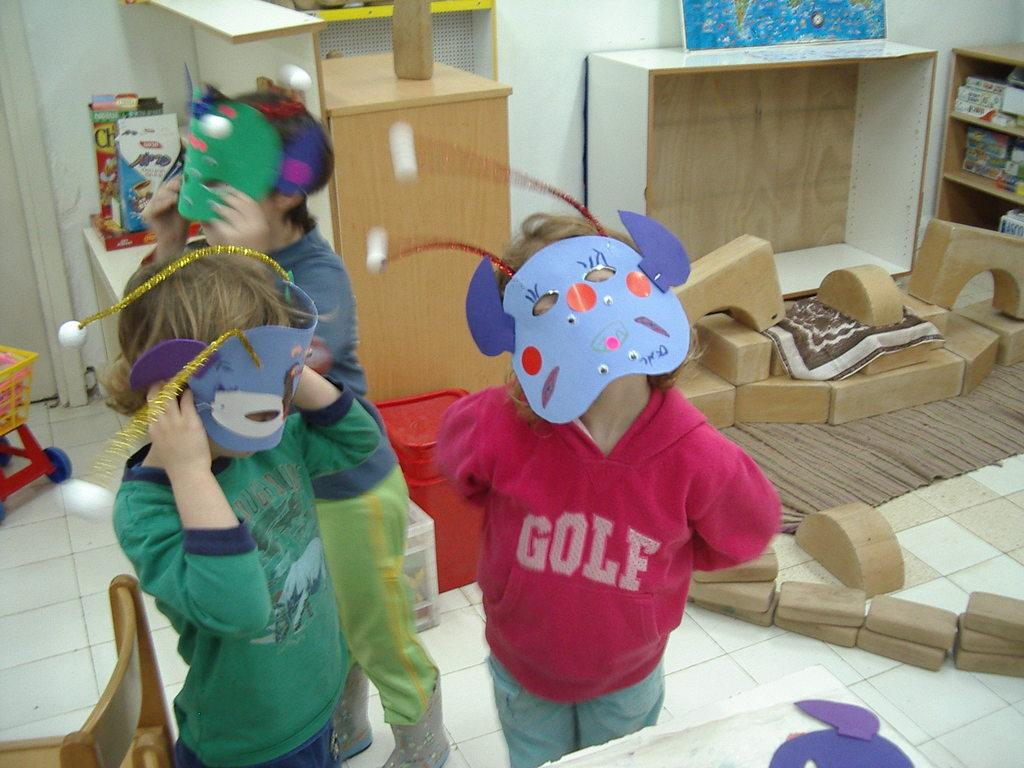What is the main setting of the image? There is a room in the image. What are the people in the room doing? The people are standing in the room and holding masks. Are the people wearing the masks they are holding? Yes, the people are wearing masks. What are the people wearing on their upper bodies? The people are wearing colorful shirts. What can be seen in the background of the room? There is a cupboard and a poster visible in the background. What year is the car featured in the image? There is no car present in the image. What color is the front of the car in the image? There is no car present in the image, so it is not possible to answer this question. 